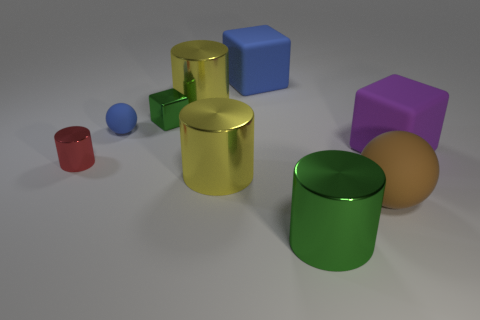Add 1 cylinders. How many objects exist? 10 Subtract all blocks. How many objects are left? 6 Add 2 shiny things. How many shiny things are left? 7 Add 1 big blue matte cylinders. How many big blue matte cylinders exist? 1 Subtract 1 red cylinders. How many objects are left? 8 Subtract all big cubes. Subtract all small rubber objects. How many objects are left? 6 